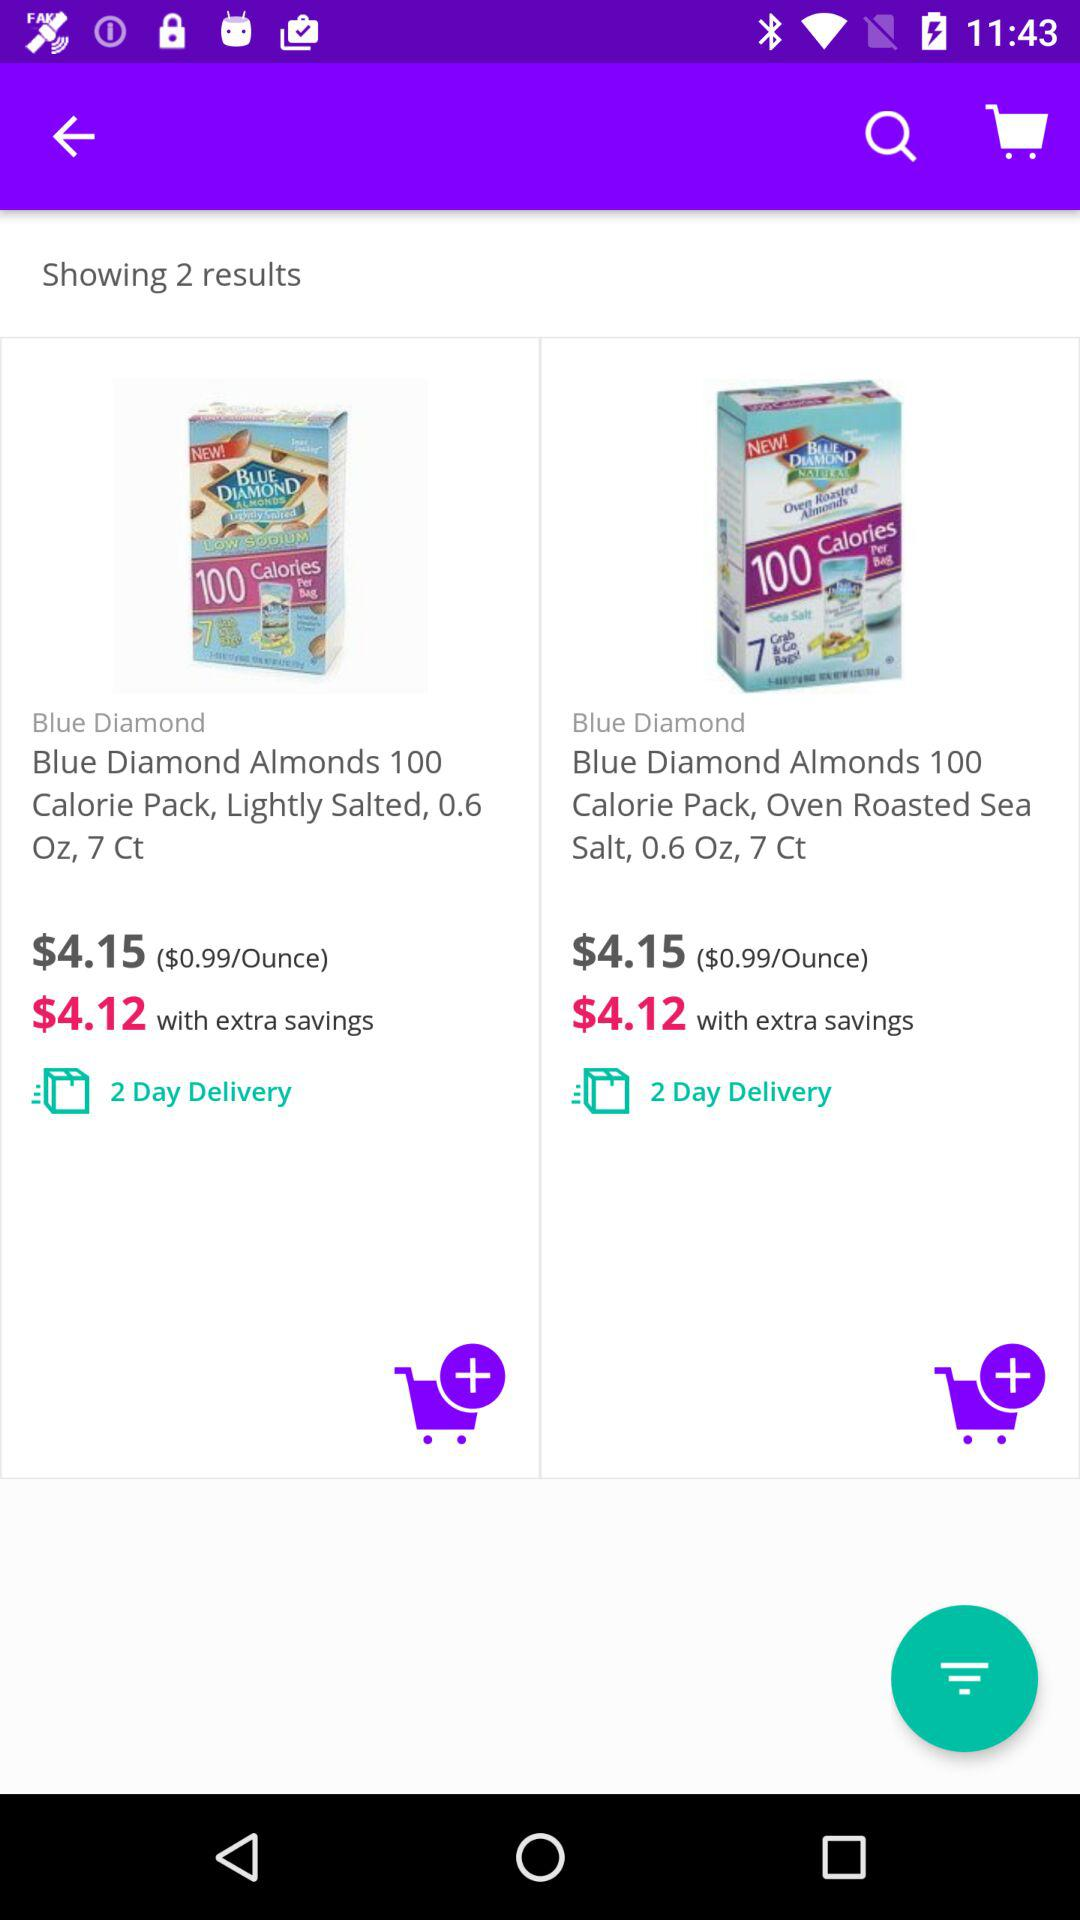How many items are available in the search results?
Answer the question using a single word or phrase. 2 